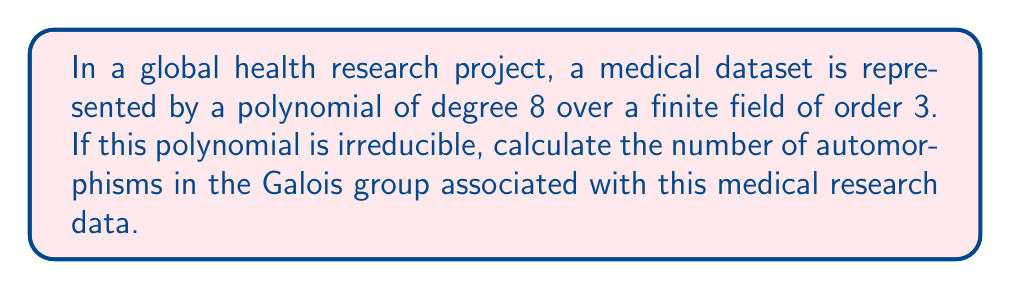Teach me how to tackle this problem. Let's approach this step-by-step:

1) The polynomial is of degree 8 over a field of order 3. This means we're working with the finite field $\mathbb{F}_3$.

2) For an irreducible polynomial of degree n over a finite field of order q, the Galois group is cyclic of order n.

3) In this case, $n = 8$ and $q = 3$.

4) The Galois group is isomorphic to the group of automorphisms of the splitting field over the base field.

5) For a finite field extension $\mathbb{F}_{q^n}/\mathbb{F}_q$, the Galois group is cyclic of order n, generated by the Frobenius automorphism $\sigma : x \mapsto x^q$.

6) The number of automorphisms in a cyclic group is equal to its order.

7) Therefore, the number of automorphisms in this Galois group is 8.

This result indicates that there are 8 distinct ways to permute the roots of the polynomial while preserving the field structure, which could be interpreted as 8 different perspectives on the medical data that preserve its fundamental relationships.
Answer: 8 